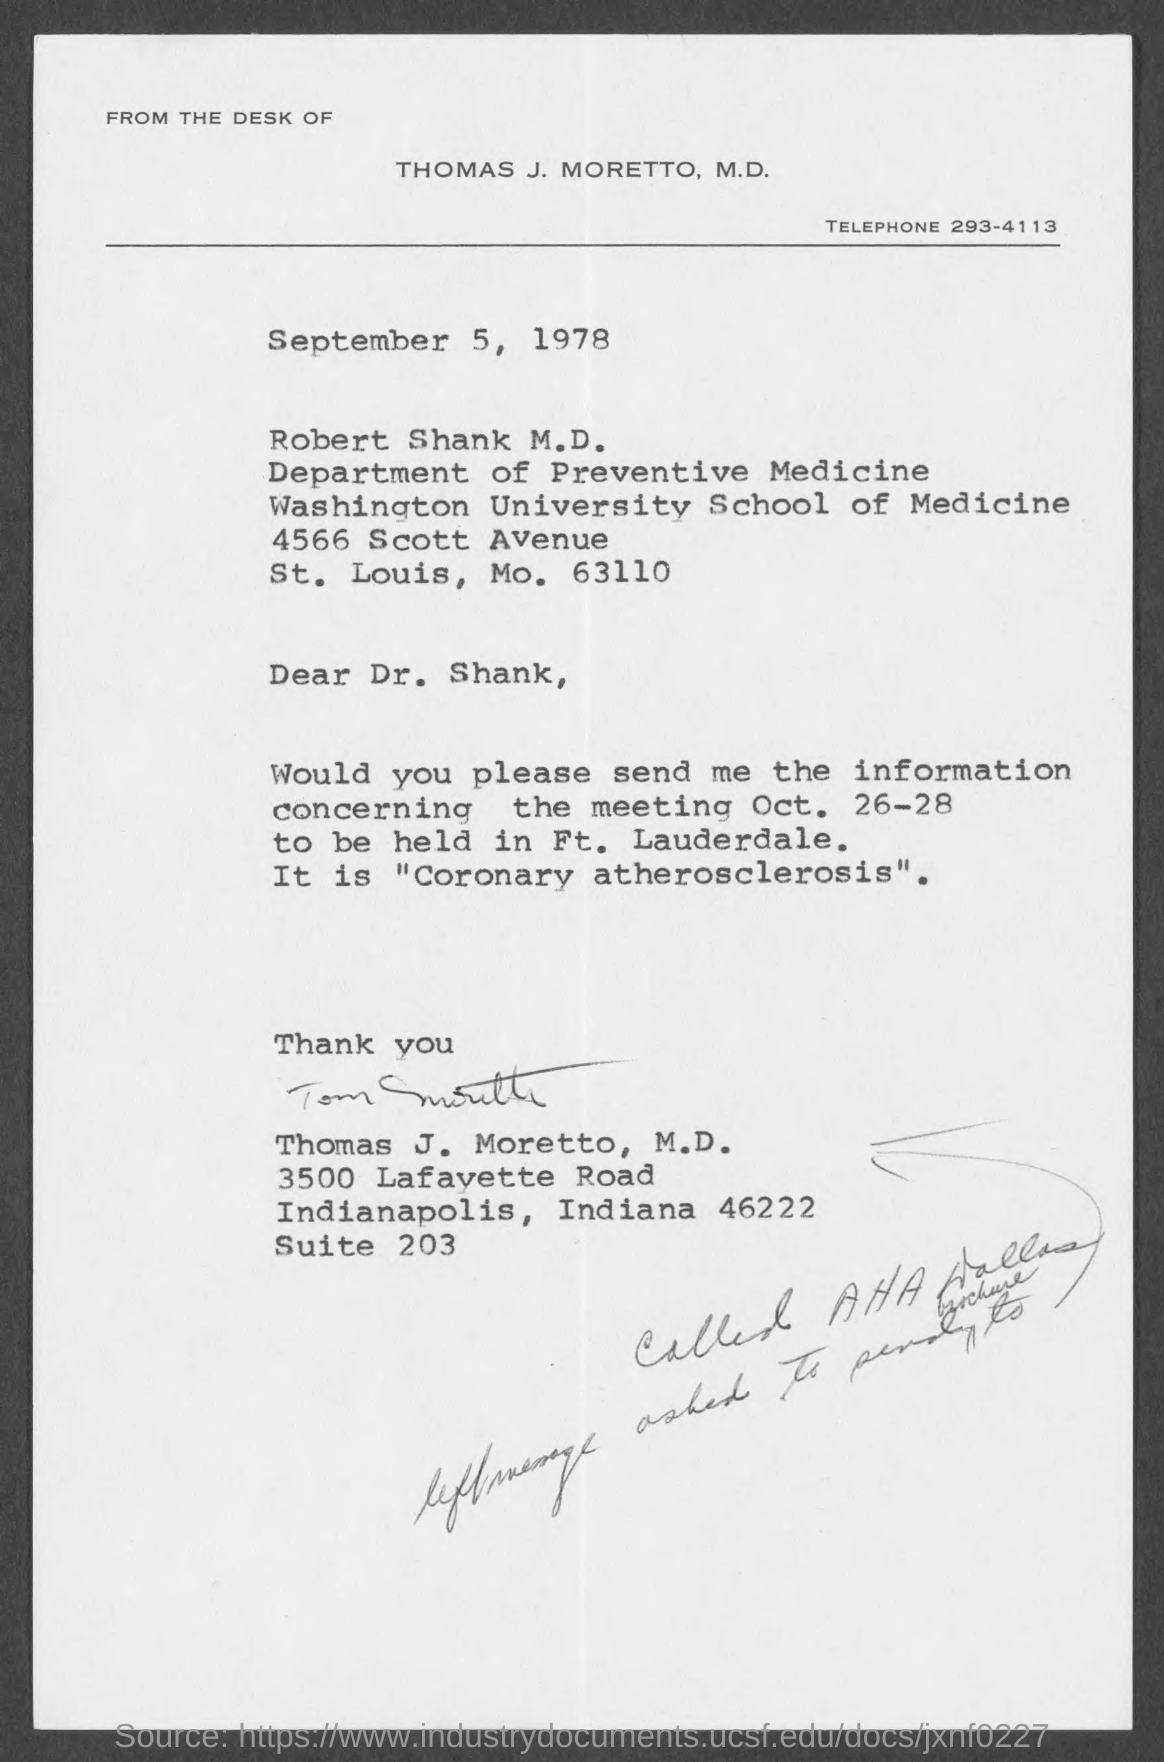Identify some key points in this picture. Robert Shank M.D. works in the Department of Preventive Medicine. The telephone number of Thomas J. Moretto, M.D. is 293-4113. The issued date of this letter is September 5, 1978. The letter has been signed by Thomas J. Moretto. 